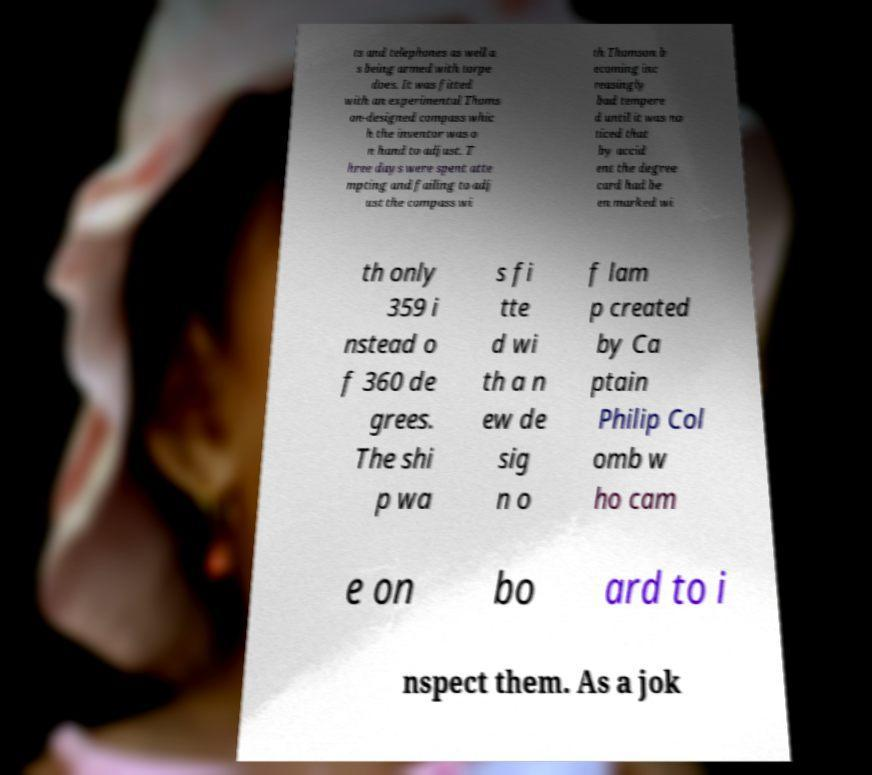What messages or text are displayed in this image? I need them in a readable, typed format. ts and telephones as well a s being armed with torpe does. It was fitted with an experimental Thoms on-designed compass whic h the inventor was o n hand to adjust. T hree days were spent atte mpting and failing to adj ust the compass wi th Thomson b ecoming inc reasingly bad tempere d until it was no ticed that by accid ent the degree card had be en marked wi th only 359 i nstead o f 360 de grees. The shi p wa s fi tte d wi th a n ew de sig n o f lam p created by Ca ptain Philip Col omb w ho cam e on bo ard to i nspect them. As a jok 